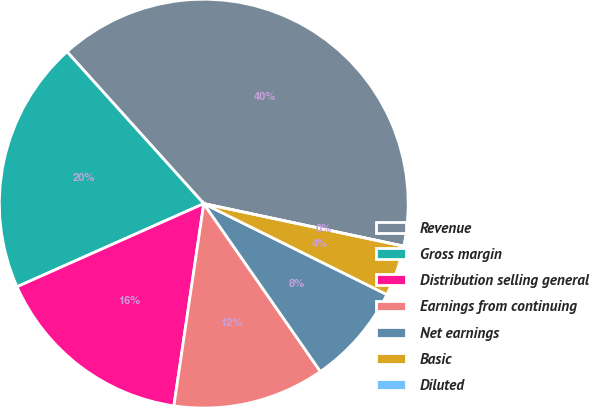Convert chart to OTSL. <chart><loc_0><loc_0><loc_500><loc_500><pie_chart><fcel>Revenue<fcel>Gross margin<fcel>Distribution selling general<fcel>Earnings from continuing<fcel>Net earnings<fcel>Basic<fcel>Diluted<nl><fcel>40.0%<fcel>20.0%<fcel>16.0%<fcel>12.0%<fcel>8.0%<fcel>4.0%<fcel>0.0%<nl></chart> 